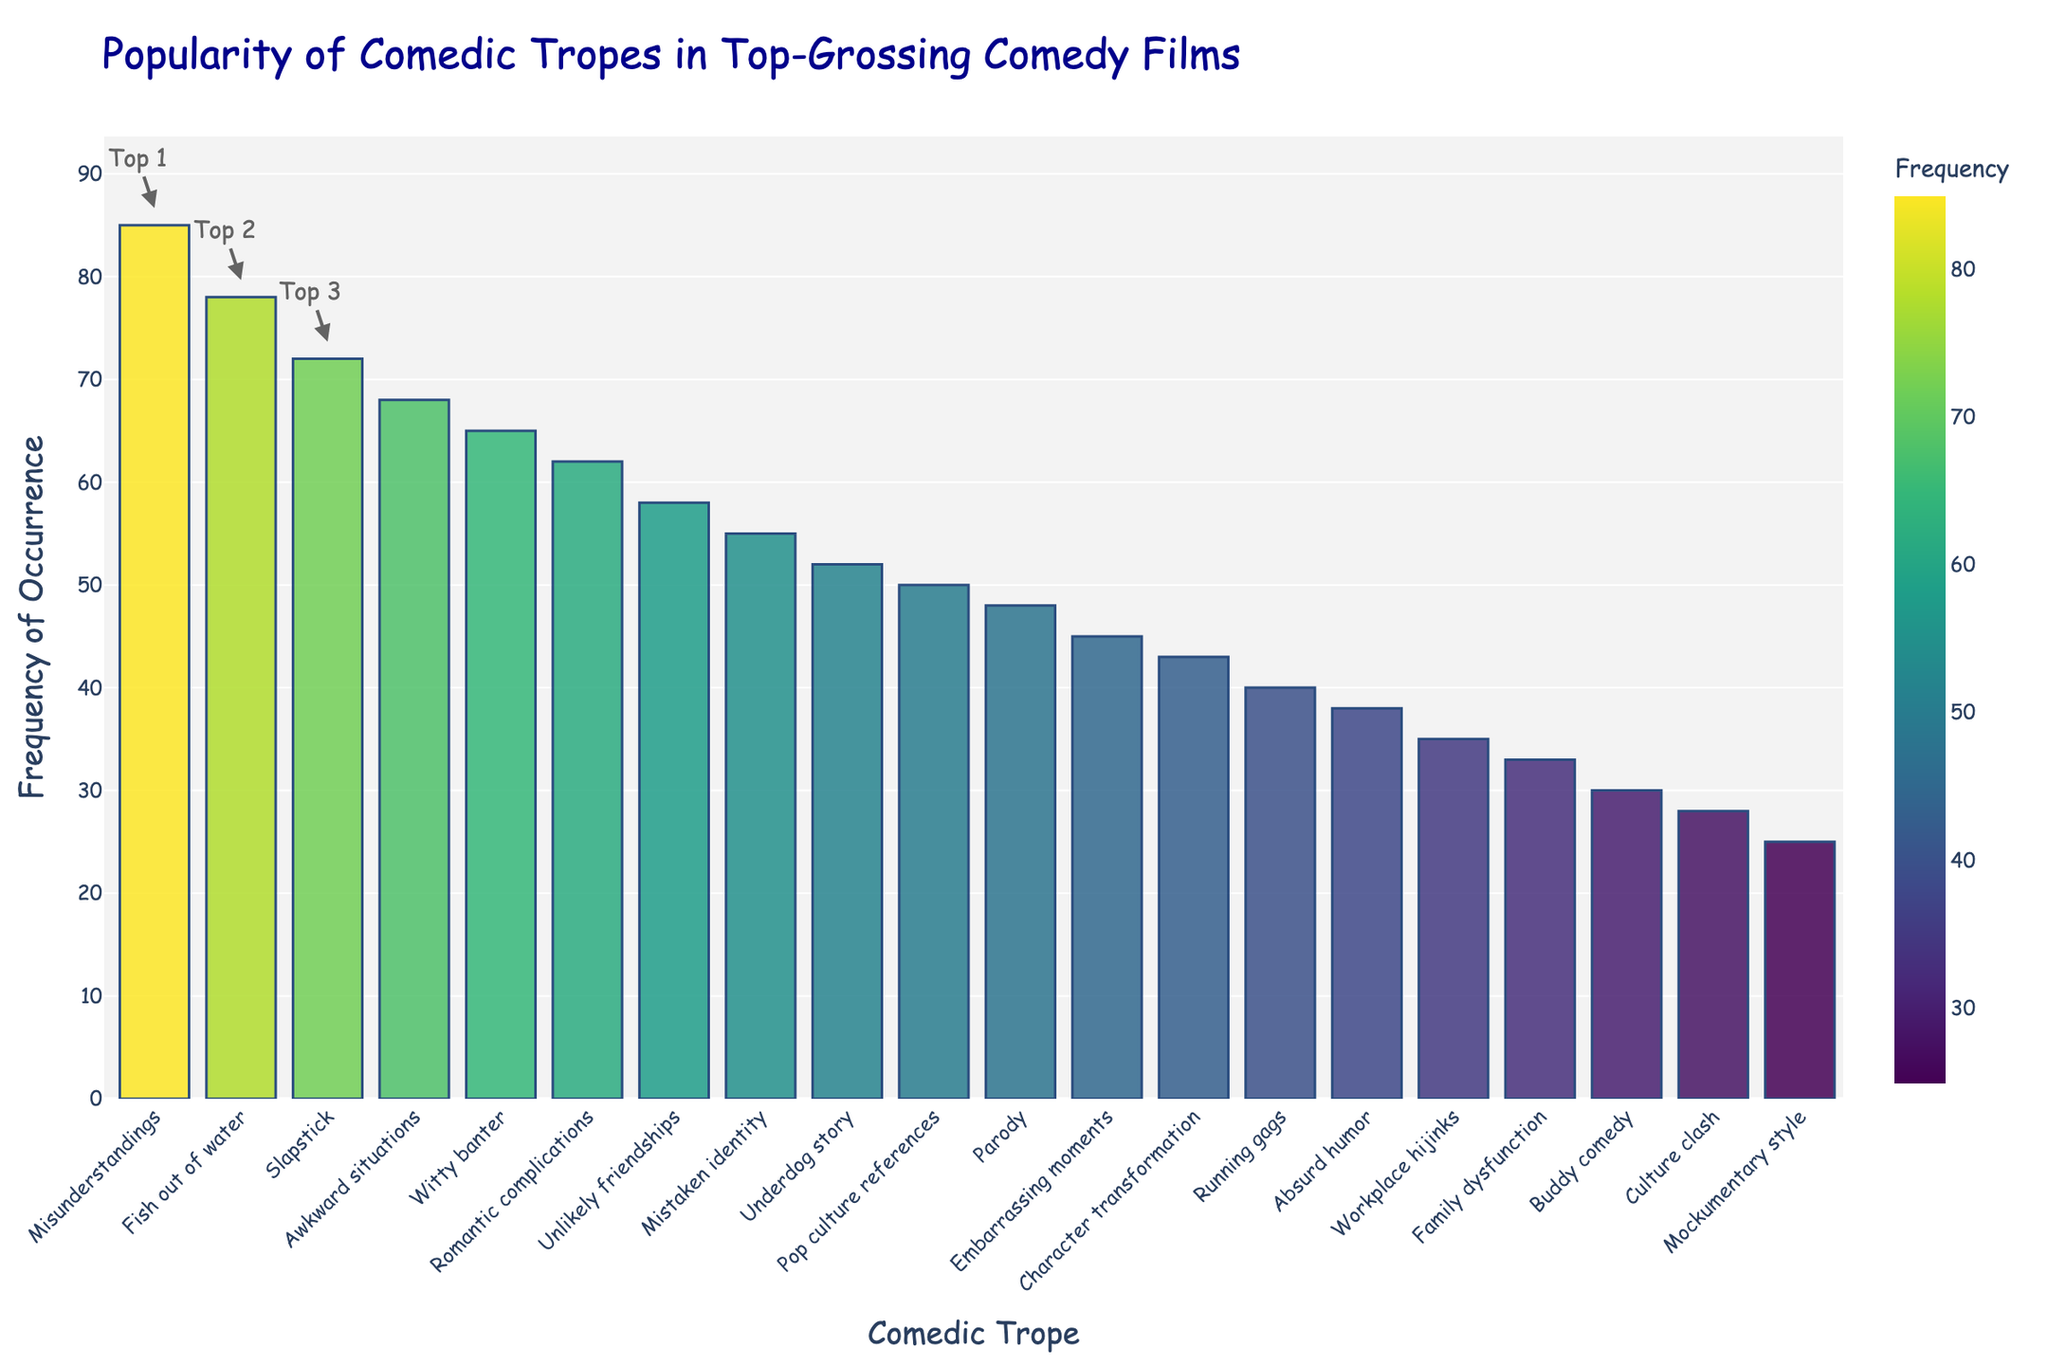Which comedic trope appears most frequently in top-grossing comedy films? To find the most frequent trope, look at the bar that has the greatest height in the figure. The tallest bar corresponds to the "Misunderstandings" trope with a frequency of 85.
Answer: Misunderstandings Which trope appears more frequently: "Buddy comedy" or "Mockumentary style"? Compare the bars for "Buddy comedy" and "Mockumentary style". The bar for "Buddy comedy" is taller than the bar for "Mockumentary style", indicating a higher frequency.
Answer: Buddy comedy How many more times does the "Fish out of water" trope appear compared to the "Absurd humor" trope? Identify the frequencies for both tropes from their bars: "Fish out of water" is 78, and "Absurd humor" is 38. Subtract 38 from 78 to find the difference. 78 - 38 = 40.
Answer: 40 What is the combined frequency of "Slapstick", "Awkward situations", and "Witty banter" tropes? Sum up the frequencies of the three tropes: "Slapstick" (72), "Awkward situations" (68), and "Witty banter" (65). 72 + 68 + 65 = 205.
Answer: 205 Is the frequency of "Romantic complications" closer to that of "Underdog story" or "Mistaken identity"? Compare the frequency of "Romantic complications" (62) to "Underdog story" (52) and "Mistaken identity" (55). The difference between "Romantic complications" and "Mistaken identity" is 7, while the difference with "Underdog story" is 10. Hence, it's closer to "Mistaken identity".
Answer: Mistaken identity How does the frequency of "Parody" compare to the frequency of "Pop culture references"? Compare the heights of the bars for "Parody" and "Pop culture references". The frequency of "Parody" is 48, and the frequency of "Pop culture references" is 50. "Parody" occurs less frequently.
Answer: Less frequent Which trope has a lower frequency: "Embarrassing moments" or "Family dysfunction"? Compare the bars for "Embarrassing moments" and "Family dysfunction". The bar for "Family dysfunction" is shorter, indicating a lower frequency.
Answer: Family dysfunction What is the median frequency of all the comedic tropes? To find the median, list all frequencies in ascending order and select the middle value. The frequencies arranged are: 25, 28, 30, 33, 35, 38, 40, 43, 45, 48, 50, 52, 55, 58, 62, 65, 68, 72, 78, 85. The middle (10th and 11th) values are 48 and 50, so the median is (48 + 50) / 2 = 49.
Answer: 49 